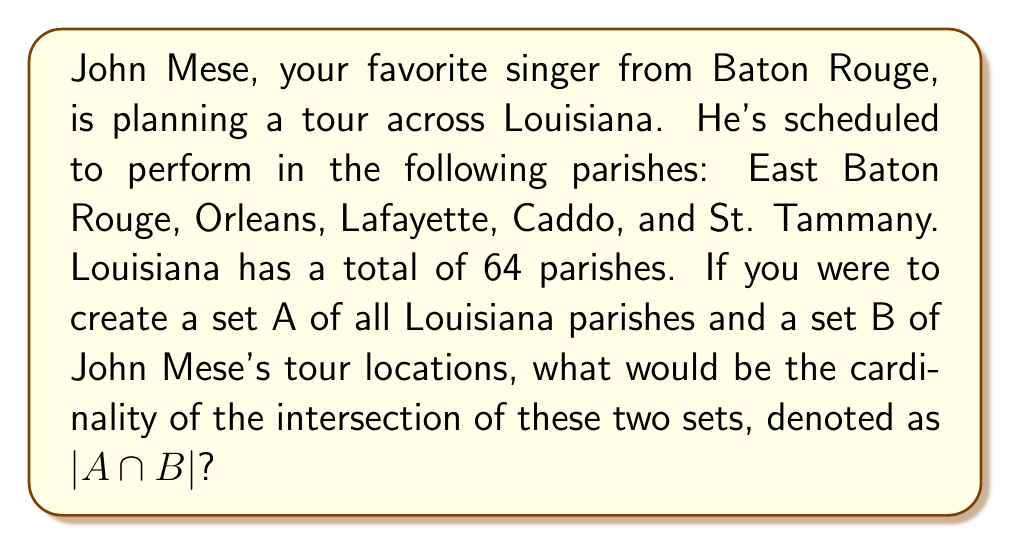Can you solve this math problem? To solve this problem, let's break it down step by step:

1. Define the sets:
   Set A = {all 64 Louisiana parishes}
   Set B = {East Baton Rouge, Orleans, Lafayette, Caddo, St. Tammany}

2. Understand the intersection:
   $A \cap B$ represents the elements that are common to both sets A and B.

3. Analyze the given information:
   - All of John Mese's tour locations are Louisiana parishes.
   - The number of tour locations (5) is less than the total number of parishes (64).

4. Determine the intersection:
   Since all elements in set B are also in set A, the intersection $A \cap B$ will contain all elements of set B.

5. Calculate the cardinality:
   $|A \cap B|$ = number of elements in set B = 5

Therefore, the cardinality of the intersection of sets A and B is 5.
Answer: $|A \cap B| = 5$ 